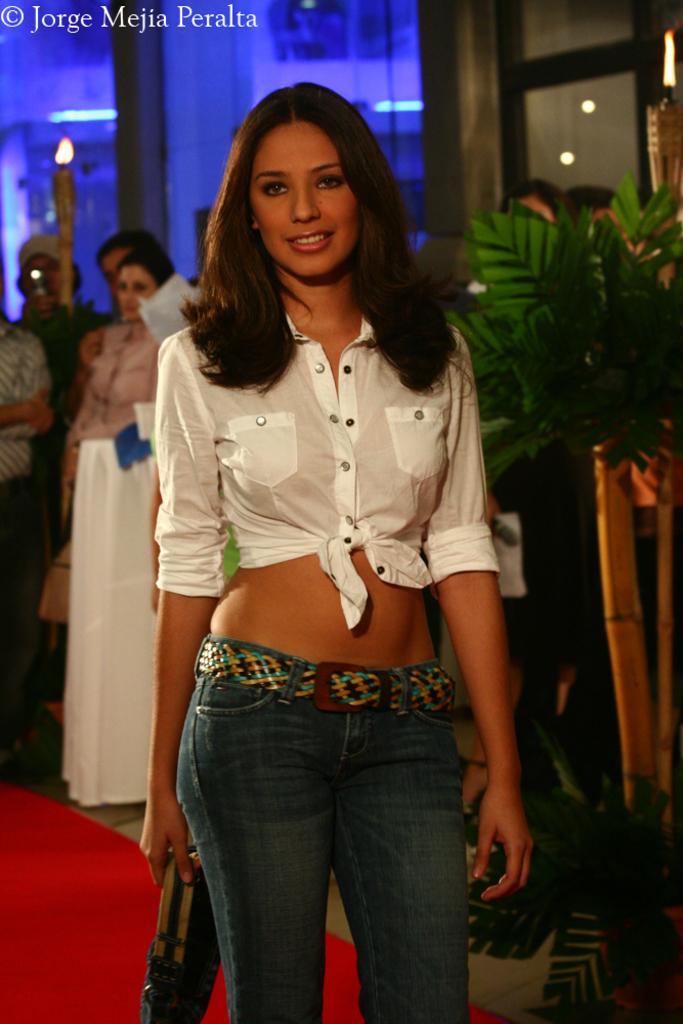Describe this image in one or two sentences. This image is taken indoors. At the bottom of the image there is a floor with a mat. In the background there is a wall and there are a few lights. A few people are standing on the floor. On the right side of the image there is a plant in the pot. In the middle of the image a girl is standing on the floor and she is holding a handbag in her hand. 